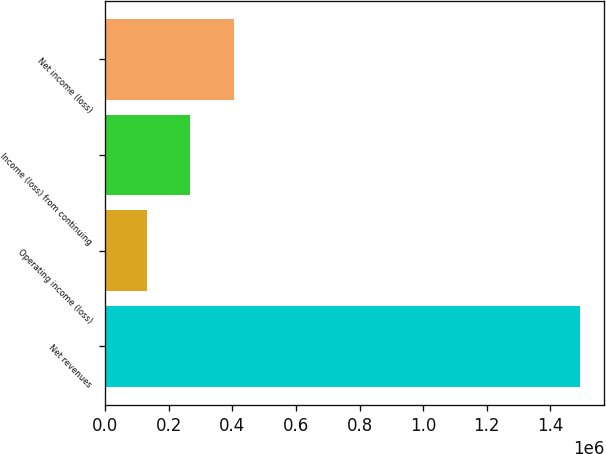Convert chart to OTSL. <chart><loc_0><loc_0><loc_500><loc_500><bar_chart><fcel>Net revenues<fcel>Operating income (loss)<fcel>Income (loss) from continuing<fcel>Net income (loss)<nl><fcel>1.49416e+06<fcel>131099<fcel>267405<fcel>403710<nl></chart> 